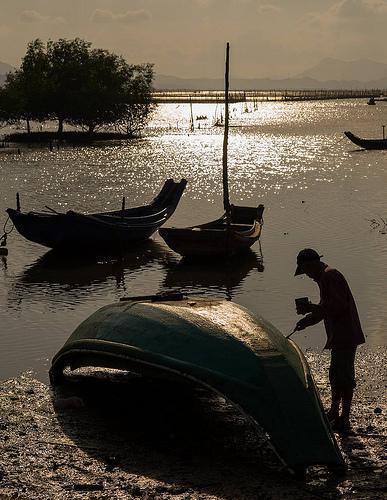How many boats are not on the water?
Give a very brief answer. 1. How many people are visible?
Give a very brief answer. 1. 